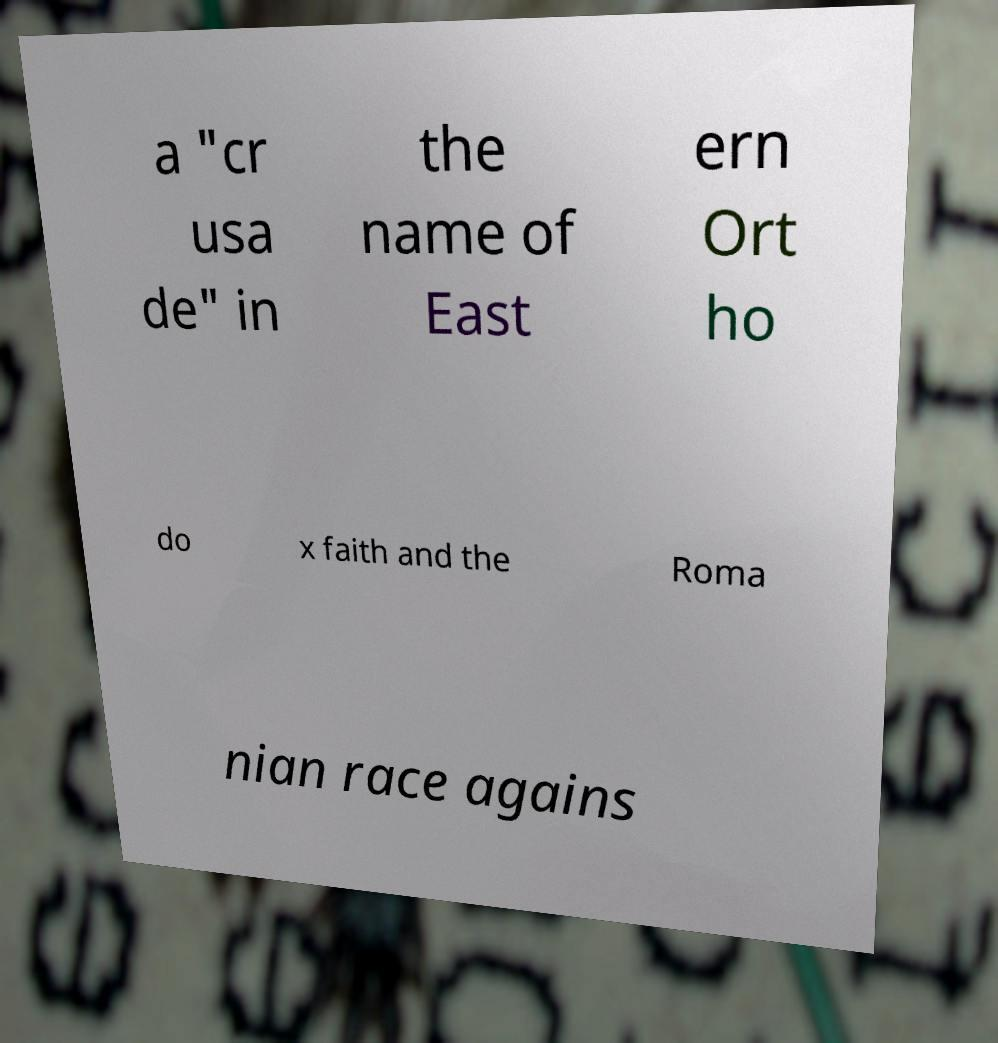I need the written content from this picture converted into text. Can you do that? a "cr usa de" in the name of East ern Ort ho do x faith and the Roma nian race agains 